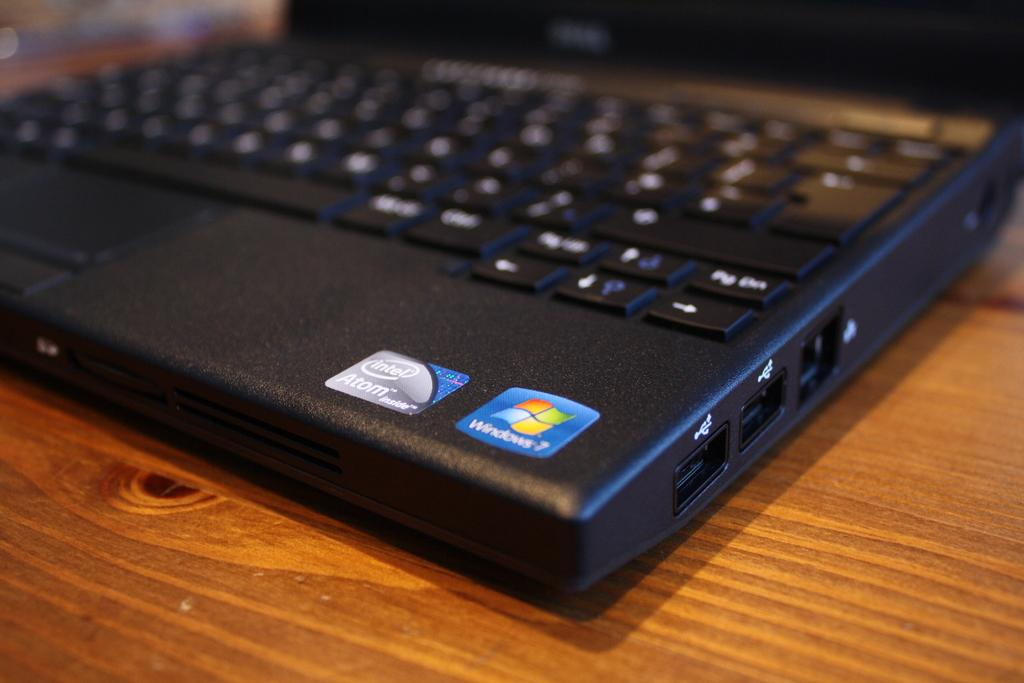What electronic device is visible in the image? There is a laptop in the image. What type of object is located at the bottom of the image? There is a wooden object at the bottom of the image. What type of cream is being used to apply a lock on the laptop in the image? There is no cream or lock present on the laptop in the image. 